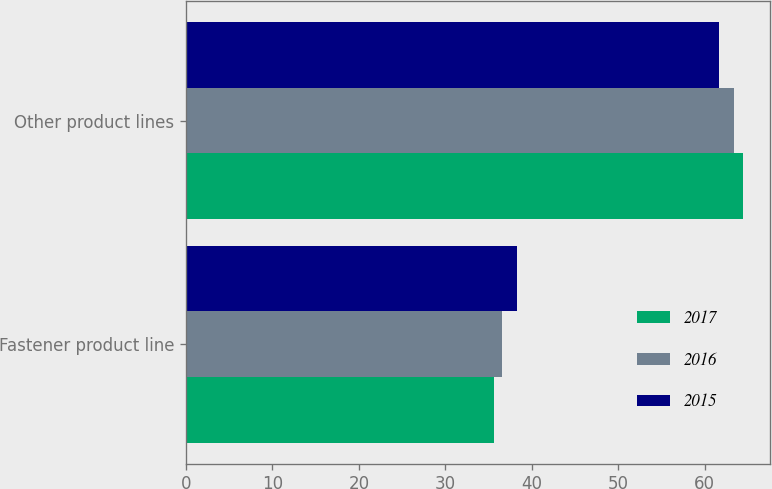Convert chart. <chart><loc_0><loc_0><loc_500><loc_500><stacked_bar_chart><ecel><fcel>Fastener product line<fcel>Other product lines<nl><fcel>2017<fcel>35.6<fcel>64.4<nl><fcel>2016<fcel>36.6<fcel>63.4<nl><fcel>2015<fcel>38.3<fcel>61.7<nl></chart> 